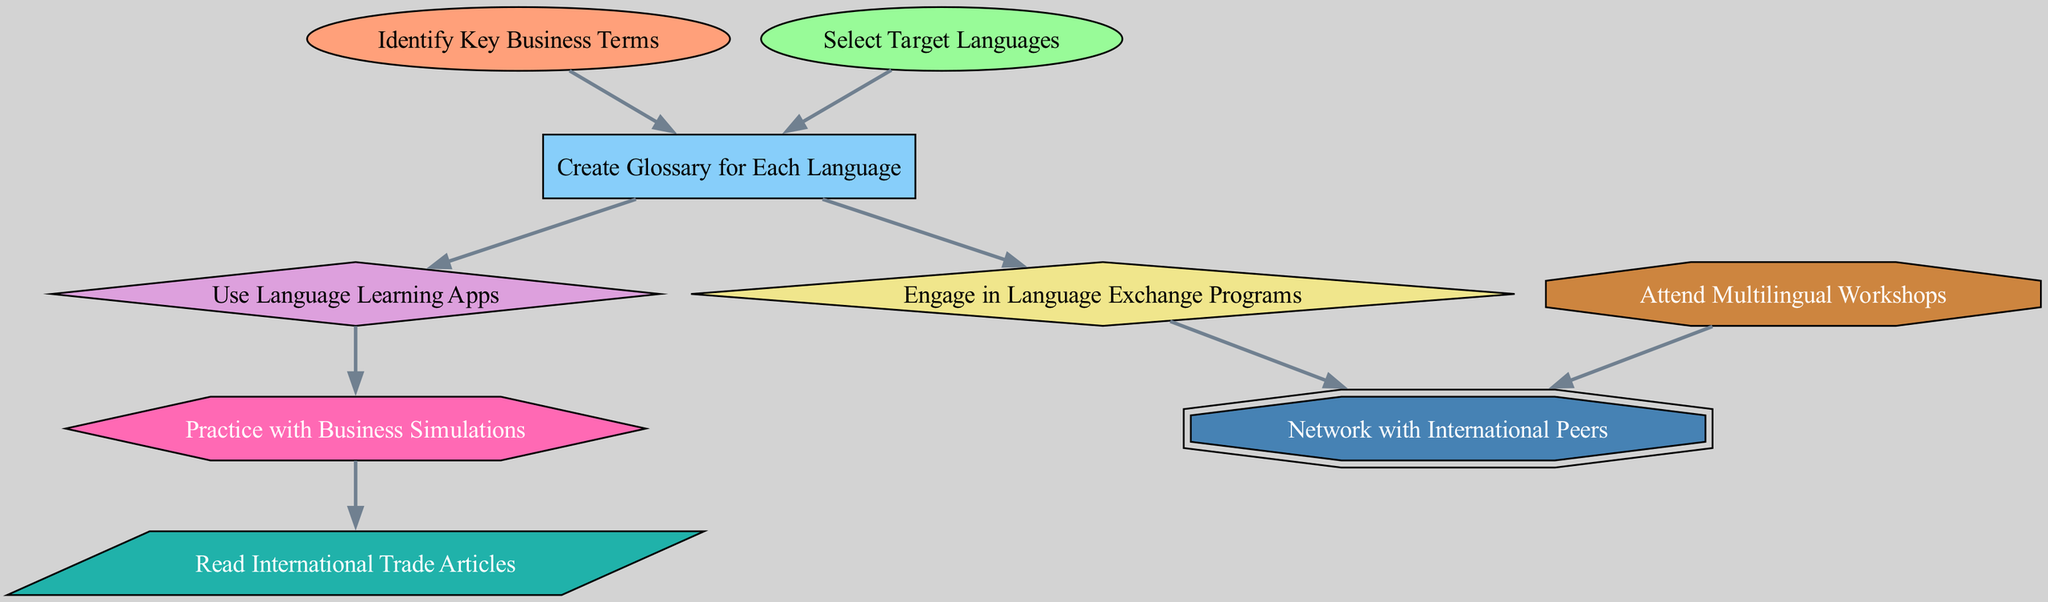What is the total number of nodes in the diagram? The diagram has a total of 9 nodes, which represent different stages and components in the roadmap for mastering business terminology across multiple languages. Each node is listed and can be counted directly from the provided data.
Answer: 9 Which node is connected to both "Identify Key Business Terms" and "Select Target Languages"? The node "Create Glossary for Each Language" has edges originating from both "Identify Key Business Terms" and "Select Target Languages," indicating that both lead to this step in the process.
Answer: Create Glossary for Each Language What type of node is "Practice with Business Simulations"? The node "Practice with Business Simulations" is depicted as a hexagon in the diagram, indicating its unique classification among the different types of learning activities represented.
Answer: hexagon How many edges are there in the diagram? By counting the connections or edges between the nodes, the diagram comprises 8 edges, displaying the relationships between the various nodes in the roadmap.
Answer: 8 Which nodes are directly connected to "Create Glossary for Each Language"? The nodes "Use Language Learning Apps" and "Engage in Language Exchange Programs" are both directly connected to "Create Glossary for Each Language," showing the subsequent steps to take after creating the glossary.
Answer: Use Language Learning Apps, Engage in Language Exchange Programs If a person attends "Multilingual Workshops," which node is connected next? After attending "Multilingual Workshops," the next connected node is "Network with International Peers," establishing a path for networking post-workshop participation.
Answer: Network with International Peers What node follows "Engage in Language Exchange Programs"? The node directly following "Engage in Language Exchange Programs" is "Network with International Peers," as indicated by the directed edge connecting these two nodes.
Answer: Network with International Peers What are the learning methods depicted in the diagram? The diagram illustrates several learning methods like "Use Language Learning Apps," "Engage in Language Exchange Programs," "Practice with Business Simulations," and "Attend Multilingual Workshops," showcasing diverse approaches to mastery of business terminology.
Answer: Use Language Learning Apps, Engage in Language Exchange Programs, Practice with Business Simulations, Attend Multilingual Workshops 